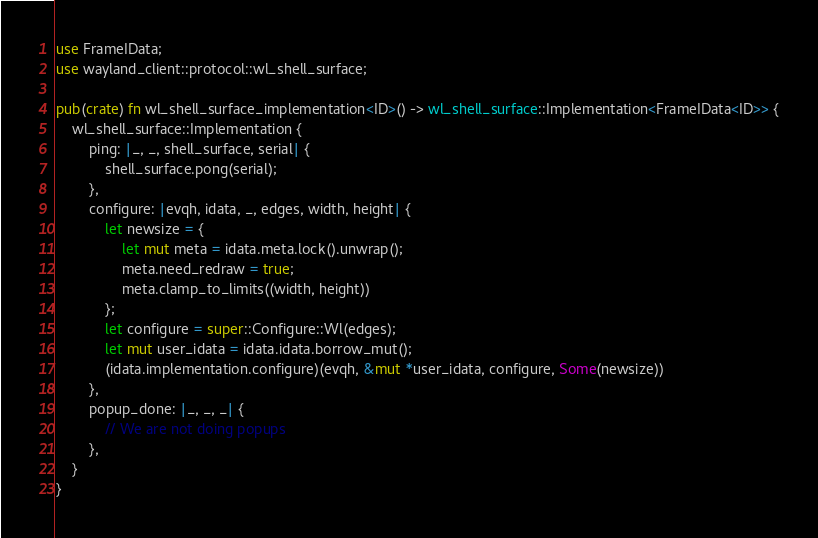Convert code to text. <code><loc_0><loc_0><loc_500><loc_500><_Rust_>use FrameIData;
use wayland_client::protocol::wl_shell_surface;

pub(crate) fn wl_shell_surface_implementation<ID>() -> wl_shell_surface::Implementation<FrameIData<ID>> {
    wl_shell_surface::Implementation {
        ping: |_, _, shell_surface, serial| {
            shell_surface.pong(serial);
        },
        configure: |evqh, idata, _, edges, width, height| {
            let newsize = {
                let mut meta = idata.meta.lock().unwrap();
                meta.need_redraw = true;
                meta.clamp_to_limits((width, height))
            };
            let configure = super::Configure::Wl(edges);
            let mut user_idata = idata.idata.borrow_mut();
            (idata.implementation.configure)(evqh, &mut *user_idata, configure, Some(newsize))
        },
        popup_done: |_, _, _| {
            // We are not doing popups
        },
    }
}
</code> 